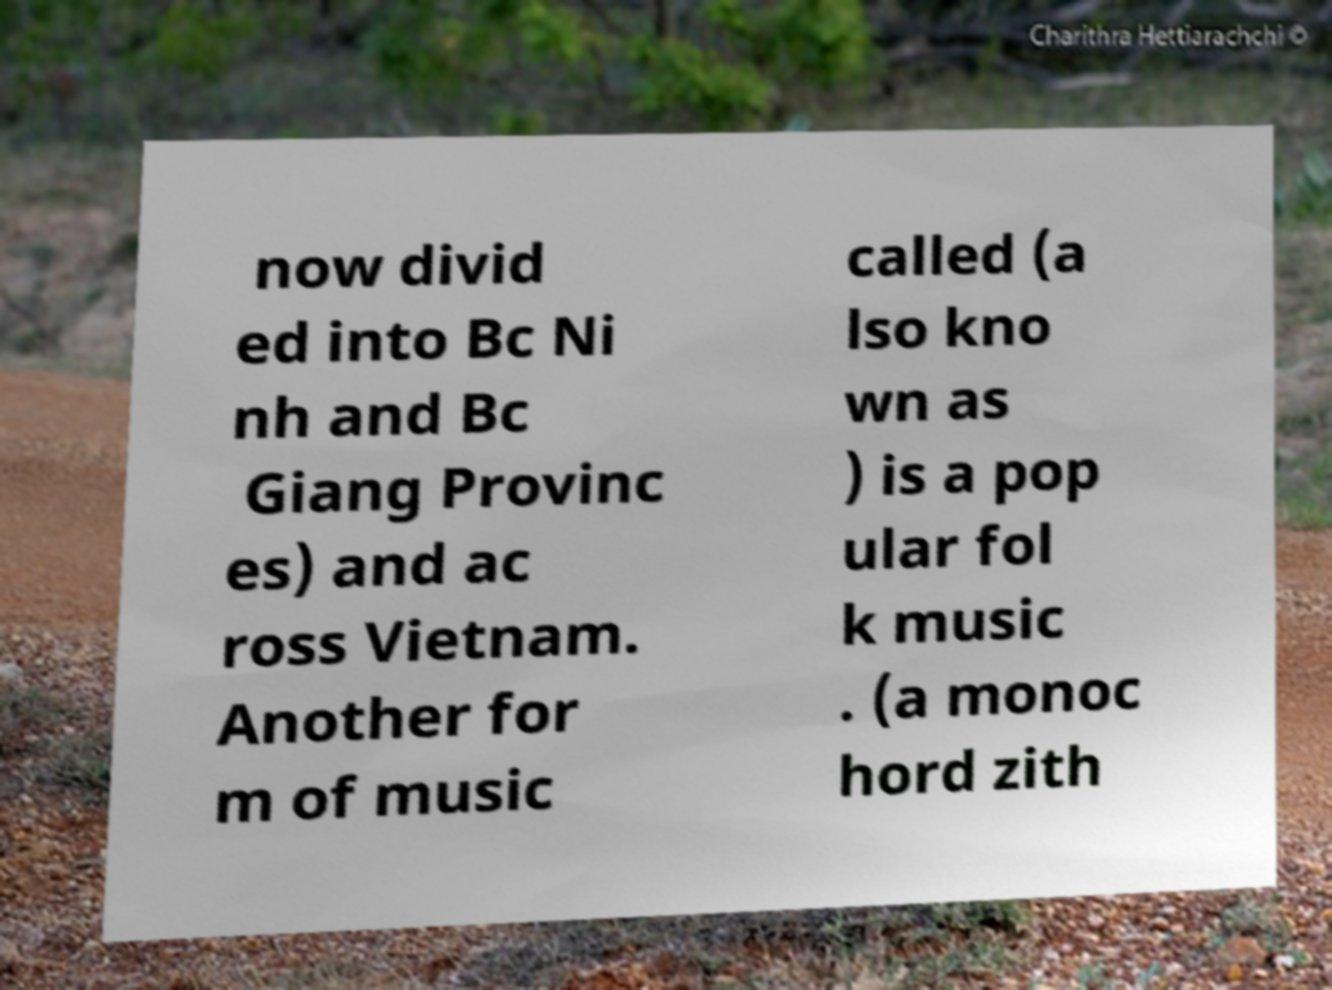Could you extract and type out the text from this image? now divid ed into Bc Ni nh and Bc Giang Provinc es) and ac ross Vietnam. Another for m of music called (a lso kno wn as ) is a pop ular fol k music . (a monoc hord zith 